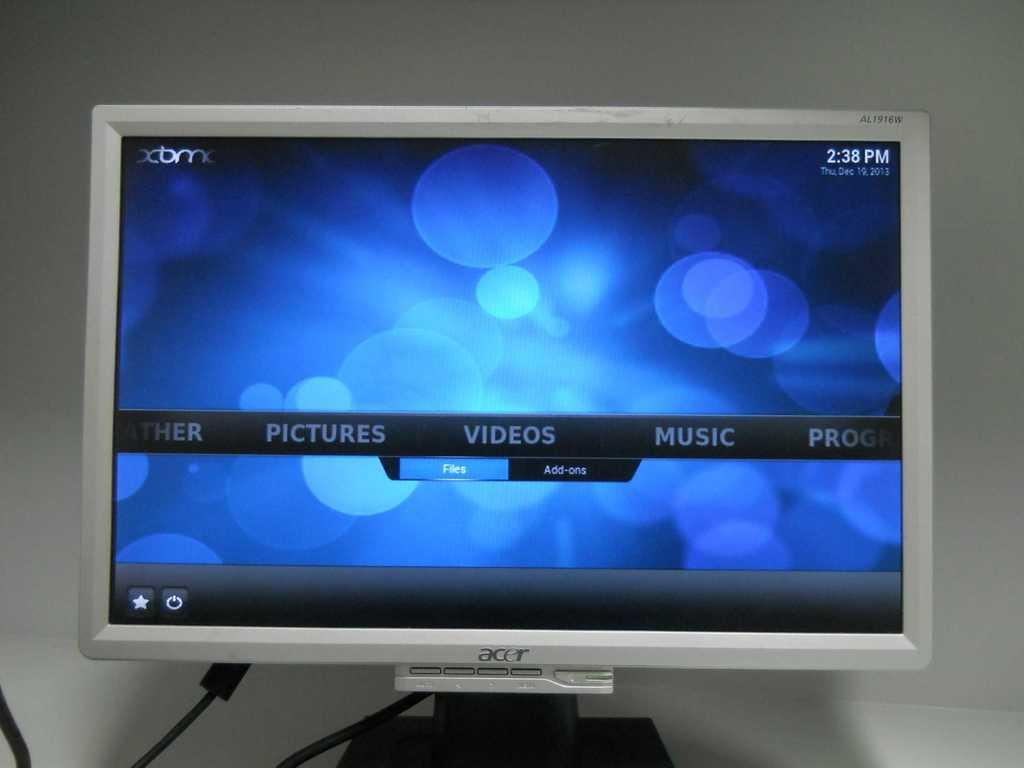<image>
Write a terse but informative summary of the picture. An acer branded monitor that has several options on what to do like videos and music. 